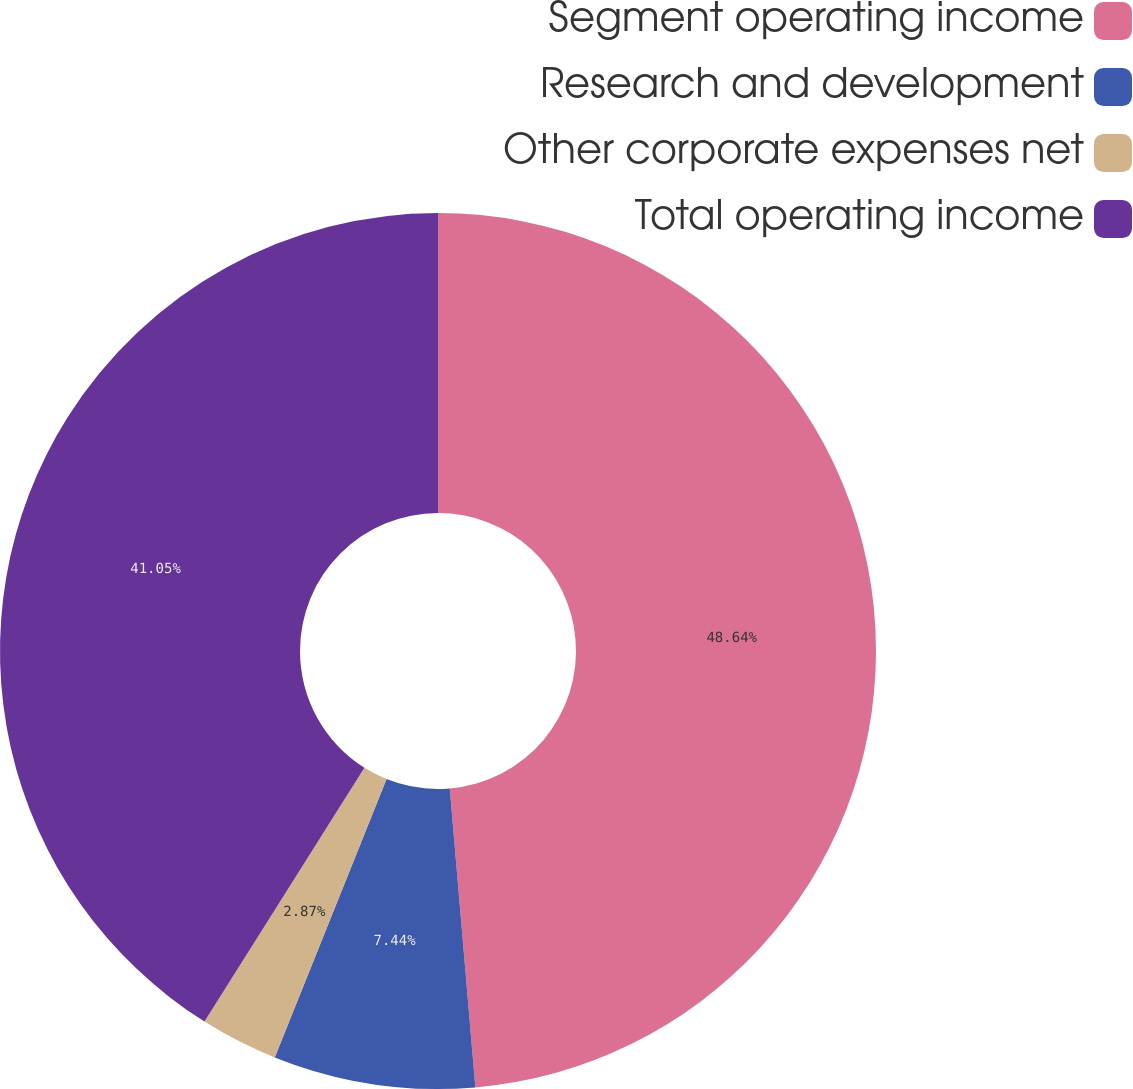Convert chart to OTSL. <chart><loc_0><loc_0><loc_500><loc_500><pie_chart><fcel>Segment operating income<fcel>Research and development<fcel>Other corporate expenses net<fcel>Total operating income<nl><fcel>48.64%<fcel>7.44%<fcel>2.87%<fcel>41.05%<nl></chart> 